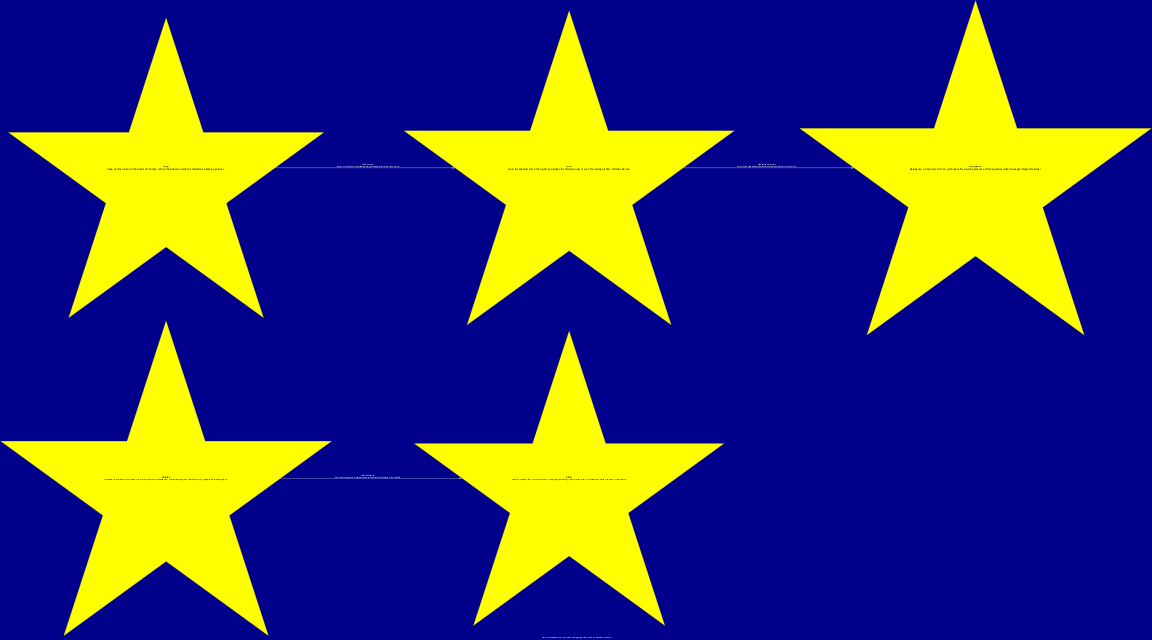What is the total number of nodes in the diagram? The diagram contains five distinct nodes representing different stars associated with Hellas Verona players.
Answer: 5 Which star symbolizes Luca Toni? The star that represents Luca Toni is Sirius, the brightest star in the night sky, as described in the node information.
Answer: Sirius How many edges are there in the diagram? There are three edges connecting the nodes, which illustrate the relationships between different player representations and their corresponding stars.
Answer: 3 What is the relationship highlighted by the edge between Sirius and Betelgeuse? The edge between Sirius and Betelgeuse is labeled "Highlighted Performers," indicating that both players were standout performers during their time at Hellas Verona.
Answer: Highlighted Performers Which constellation is Antares associated with? Antares is known as the heart of the Scorpion constellation, as mentioned in its description in the diagram.
Answer: Scorpion What do the nodes Altair and Antares represent collectively? Altair and Antares are connected by the edge labeled "Midfield Maestros," which signifies players known for their skill and influence in the midfield.
Answer: Midfield Maestros Who is described as a legendary striker in the diagram? The diagram describes Giuseppe 'Beppe' Galderisi as the legendary striker who is represented by the star Betelgeuse.
Answer: Giuseppe 'Beppe' Galderisi Which stars are represented as 'star' attackers in the diagram? The edge labeled "Star Attackers" connects Vega and Sirius, indicating that these stars correspond to top goal-scoring talents in Hellas Verona's history.
Answer: Vega and Sirius 